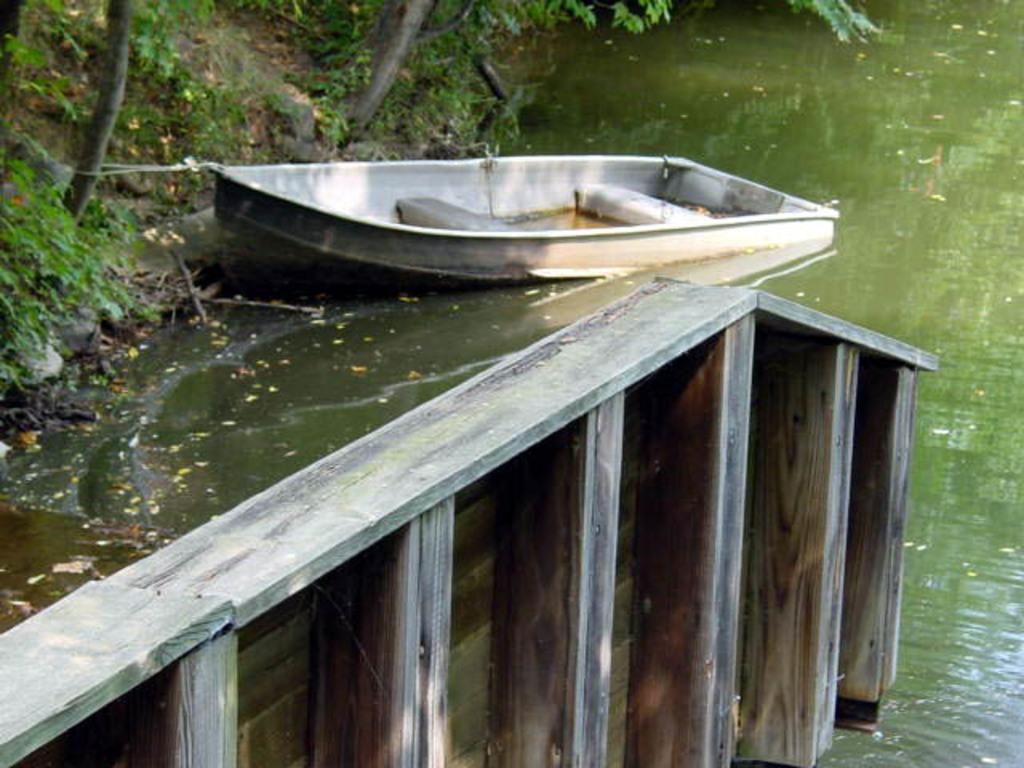What is in the water in the image? There is a boat in the water in the image. What type of material is used for the fencing in the image? The fencing in the image is made of wood. What type of vegetation is present in the image? There are trees and grass in the image. Reasoning: Let'g: Let's think step by step in order to produce the conversation. We start by identifying the main subject in the image, which is the boat in the water. Then, we expand the conversation to include other elements of the image, such as the wooden fencing, trees, and grass. Each question is designed to elicit a specific detail about the image that is known from the provided facts. Absurd Question/Answer: What year is depicted in the image? The image does not depict a specific year; it is a snapshot of a scene with a boat, wooden fencing, trees, and grass. What type of net is being used to catch fish in the image? There is no net present in the image, nor is there any indication of fishing activity. What type of cream is being used to paint the trees in the image? There is no cream being used to paint the trees in the image; the trees are natural and not painted. 